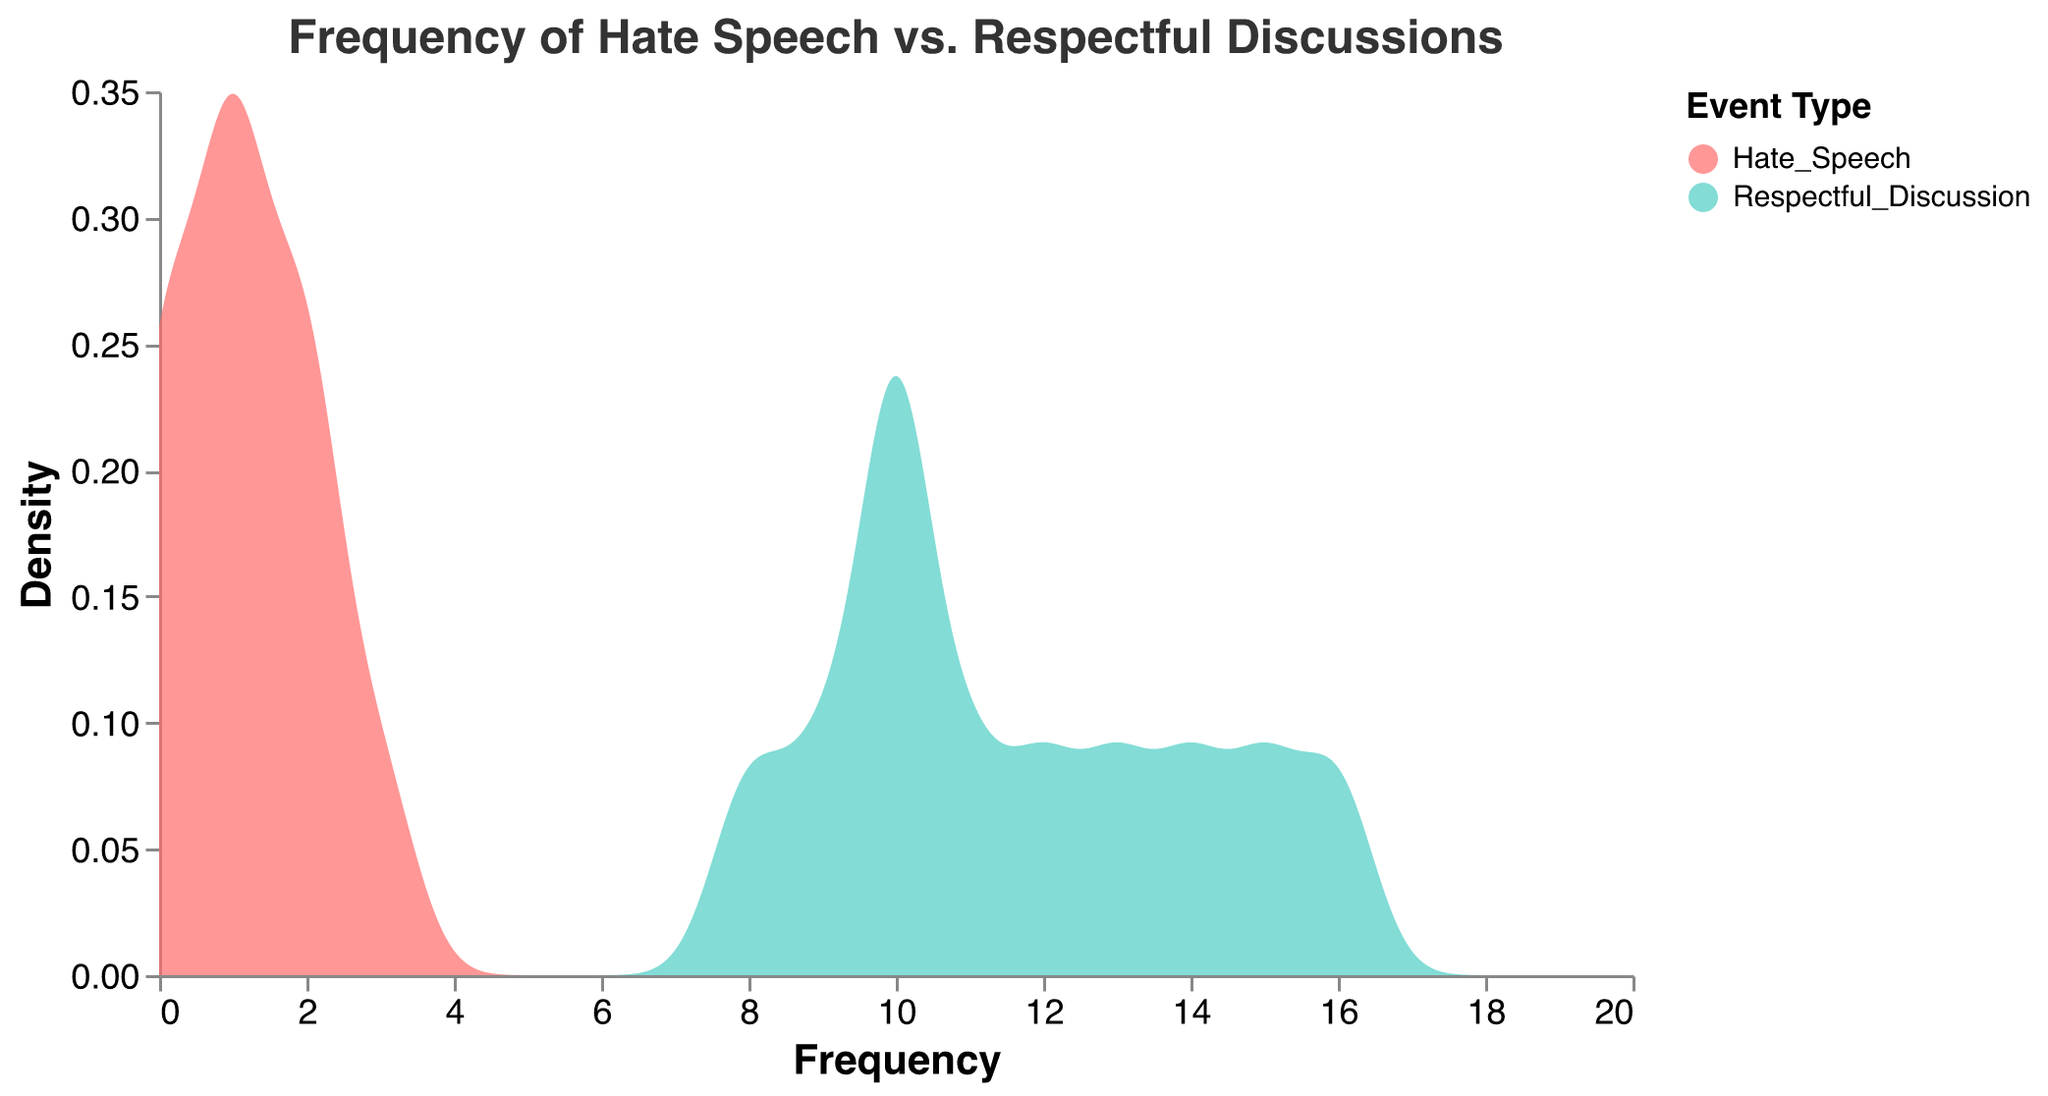What title is given to the density plot? The title of a density plot is prominently displayed at the top. It reads "Frequency of Hate Speech vs. Respectful Discussions".
Answer: Frequency of Hate Speech vs. Respectful Discussions What are the two different event types displayed in the plot? The legend at the right side of the plot shows two colored categories corresponding to the events: one is "Hate_Speech" and the other is "Respectful_Discussion".
Answer: Hate_Speech and Respectful_Discussion Which event type has a higher peak density value in the plot? By examining the height of the density curves, it is visible that the peak of the turquoise-colored "Respectful_Discussion" curve is higher than that of the red-colored "Hate_Speech" curve.
Answer: Respectful_Discussion How many incident types were reported with a frequency of zero? The plot shows density curves that start from zero frequencies on the x-axis. By tracing the density lines back to the y-axis, we can see that both types have non-zero densities near the frequency zero. This indicates that both "Hate_Speech" and "Respectful_Discussion" have incidents with a frequency of zero.
Answer: Two At which frequency range does "Respectful_Discussion" have the highest density? The peak of the "Respectful_Discussion" density curve indicates where it achieves its maximum density. Observing the graph, this appears to be around the frequency range of 10 to 15 on the x-axis.
Answer: Around 10 to 15 Which frequency range shows a higher density for "Hate_Speech" compared to "Respectful_Discussion"? To assess this, look for regions along the x-axis where the red "Hate_Speech" curve is higher than the turquoise "Respectful_Discussion" curve. This primarily occurs between x-values of 0 to 2.
Answer: 0 to 2 Overall, which event type shows a broader range of frequencies? Comparing the width of both density curves, "Respectful_Discussion" spans a broader range of frequencies, stretching from about 0 to 16, whereas "Hate_Speech" has a more confined range up to around 3.
Answer: Respectful_Discussion How do the colors differentiate the event types in the plot, and what are they? The plot uses specific colors to represent different event types. According to the legend, "Hate_Speech" is represented by red and "Respectful_Discussion" by turquoise. This color scheme facilitates easy identification of the two event types on the plot.
Answer: Hate_Speech is red and Respectful_Discussion is turquoise Is there a correlation between the density of "Hate_Speech" and "Respectful_Discussion"? The density plot itself doesn't explicitly show correlation but we can infer it by observing overlap patterns. Both curves share some frequency ranges but "Respectful_Discussion" distributions are consistently higher and broader, indicating no direct positive correlation between the two densities.
Answer: No direct correlation 